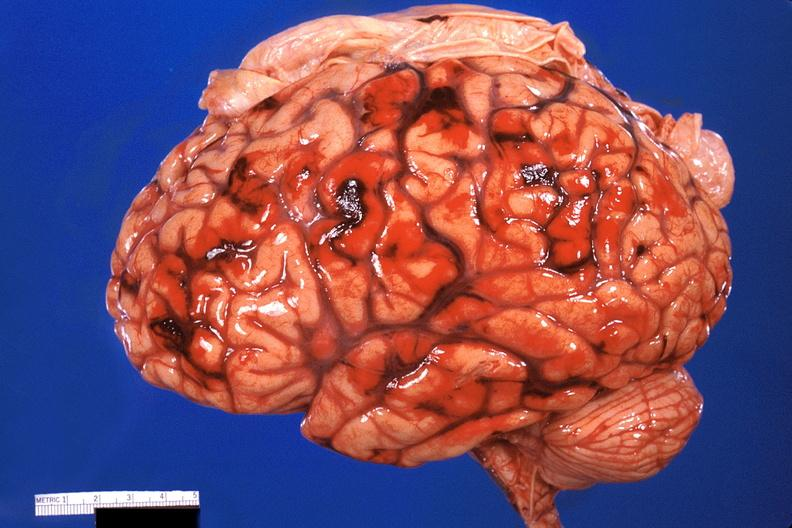what is present?
Answer the question using a single word or phrase. Nervous 